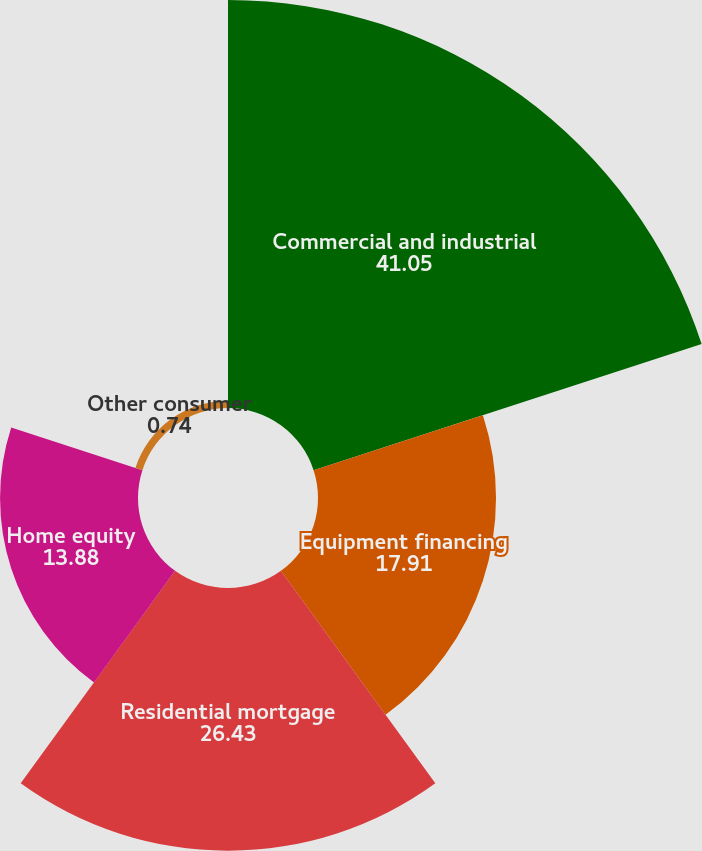<chart> <loc_0><loc_0><loc_500><loc_500><pie_chart><fcel>Commercial and industrial<fcel>Equipment financing<fcel>Residential mortgage<fcel>Home equity<fcel>Other consumer<nl><fcel>41.05%<fcel>17.91%<fcel>26.43%<fcel>13.88%<fcel>0.74%<nl></chart> 